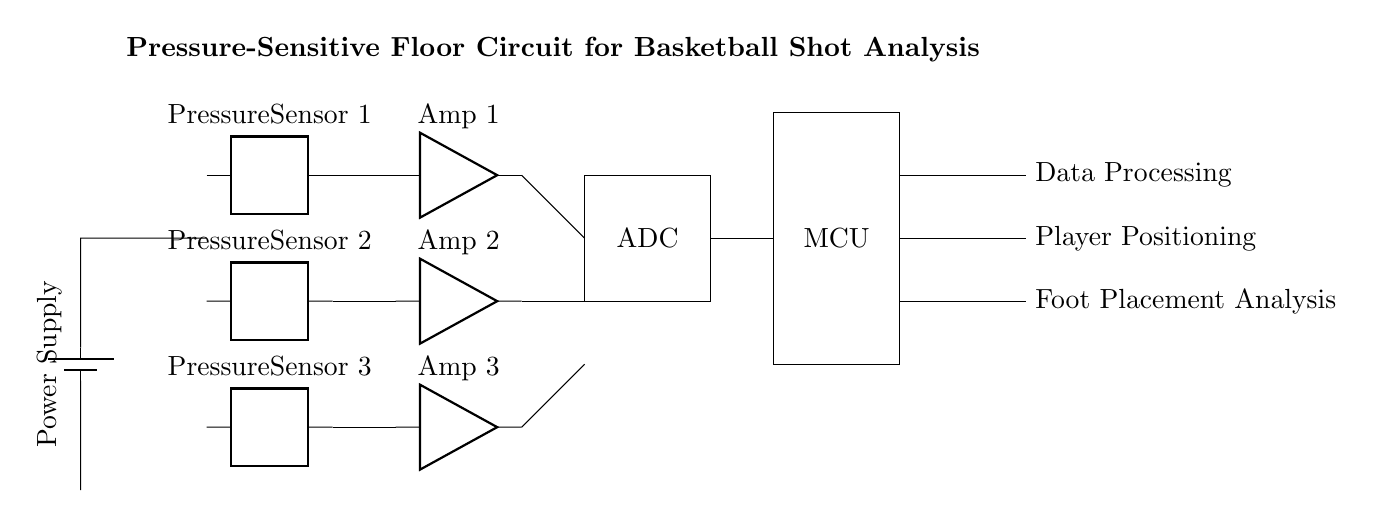What types of sensors are used in this circuit? The circuit includes three pressure sensors, labeled as Pressure Sensor 1, Pressure Sensor 2, and Pressure Sensor 3.
Answer: Pressure sensors How many amplifiers are present in the circuit? There are three amplifiers, one for each pressure sensor. They are labeled as Amp 1, Amp 2, and Amp 3.
Answer: Three amplifiers What component processes the sensor data? The microcontroller (MCU) processes the data received from the amplifiers and the ADC.
Answer: Microcontroller What is the role of the ADC in this circuit? The ADC (Analog-to-Digital Converter) converts the analog signals from the amplifiers into digital signals for further processing by the microcontroller.
Answer: Convert analog signals Which component supplies power to the circuit? The power supply, represented by a battery in the circuit, supplies the necessary power to operate the sensors and other components.
Answer: Power supply How do the sensors connect to the amplifiers? Each pressure sensor connects to its corresponding amplifier with a direct line. For example, Pressure Sensor 1 connects to Amp 1 directly.
Answer: Direct line connections What analysis is performed on the data processed by the microcontroller? The microcontroller performs player positioning and foot placement analysis based on the data it processes from the sensors and amplifiers.
Answer: Foot placement analysis 